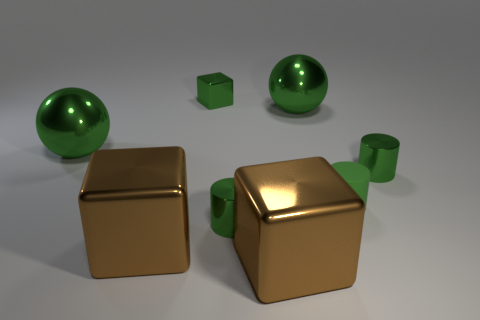Subtract all green cylinders. How many were subtracted if there are1green cylinders left? 2 Add 2 shiny balls. How many objects exist? 10 Subtract all cubes. How many objects are left? 5 Subtract all large shiny cubes. Subtract all small metal cylinders. How many objects are left? 4 Add 7 large brown objects. How many large brown objects are left? 9 Add 2 small green blocks. How many small green blocks exist? 3 Subtract 2 green cylinders. How many objects are left? 6 